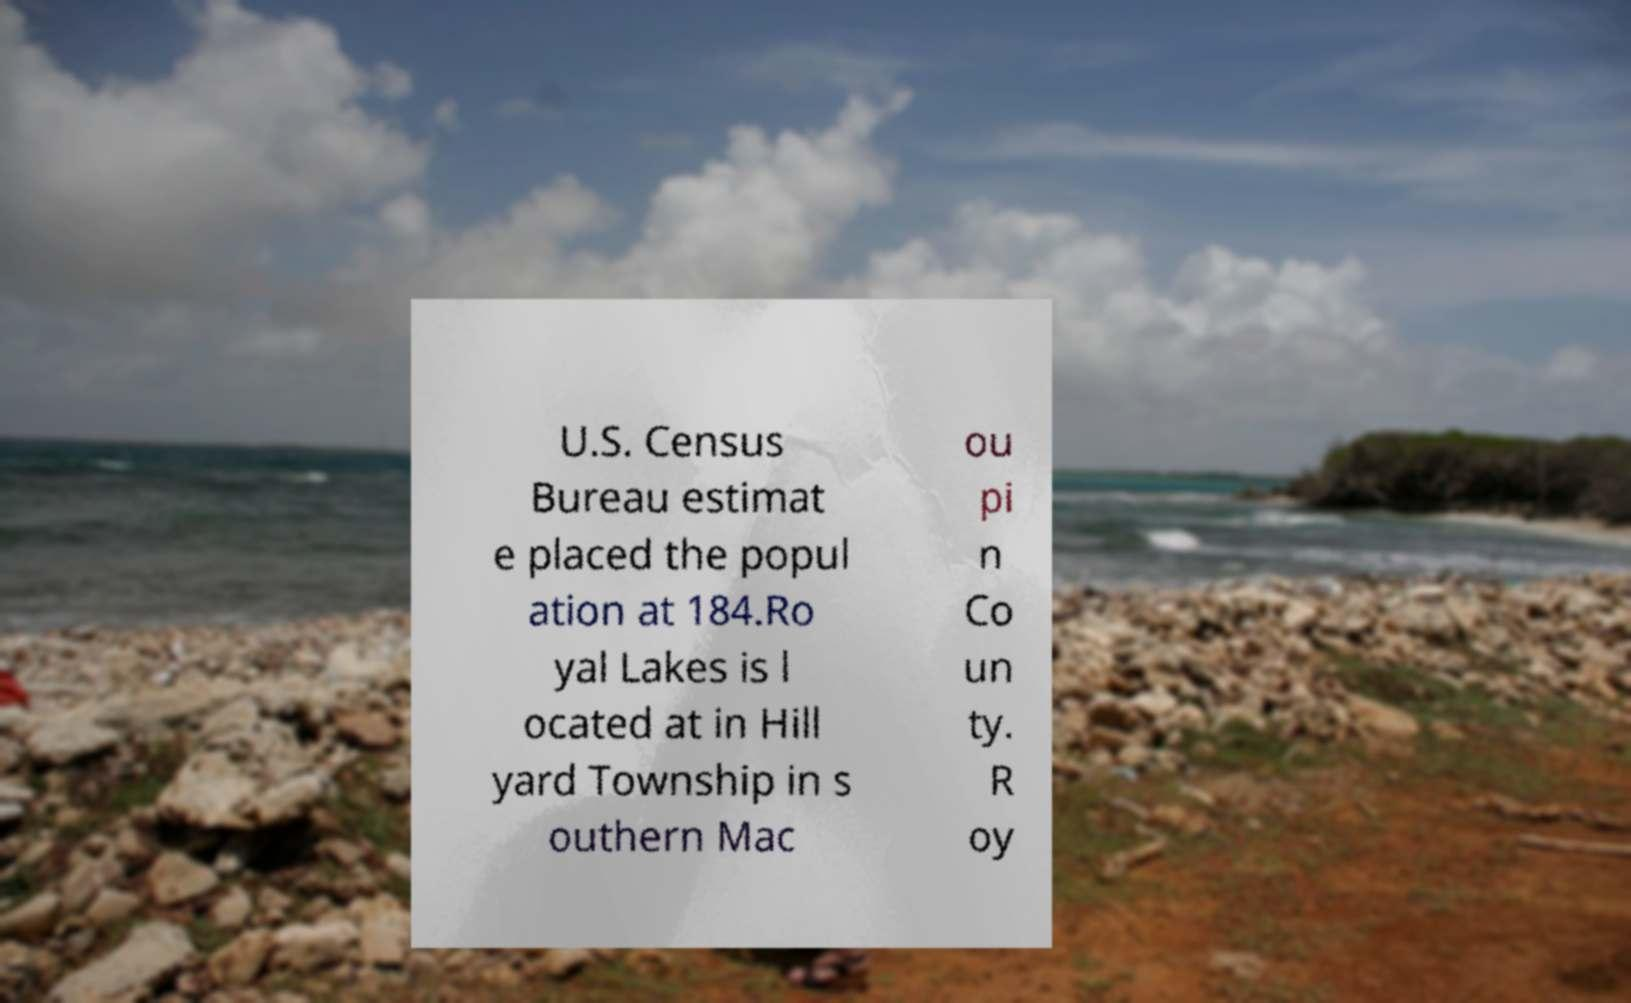Could you assist in decoding the text presented in this image and type it out clearly? U.S. Census Bureau estimat e placed the popul ation at 184.Ro yal Lakes is l ocated at in Hill yard Township in s outhern Mac ou pi n Co un ty. R oy 